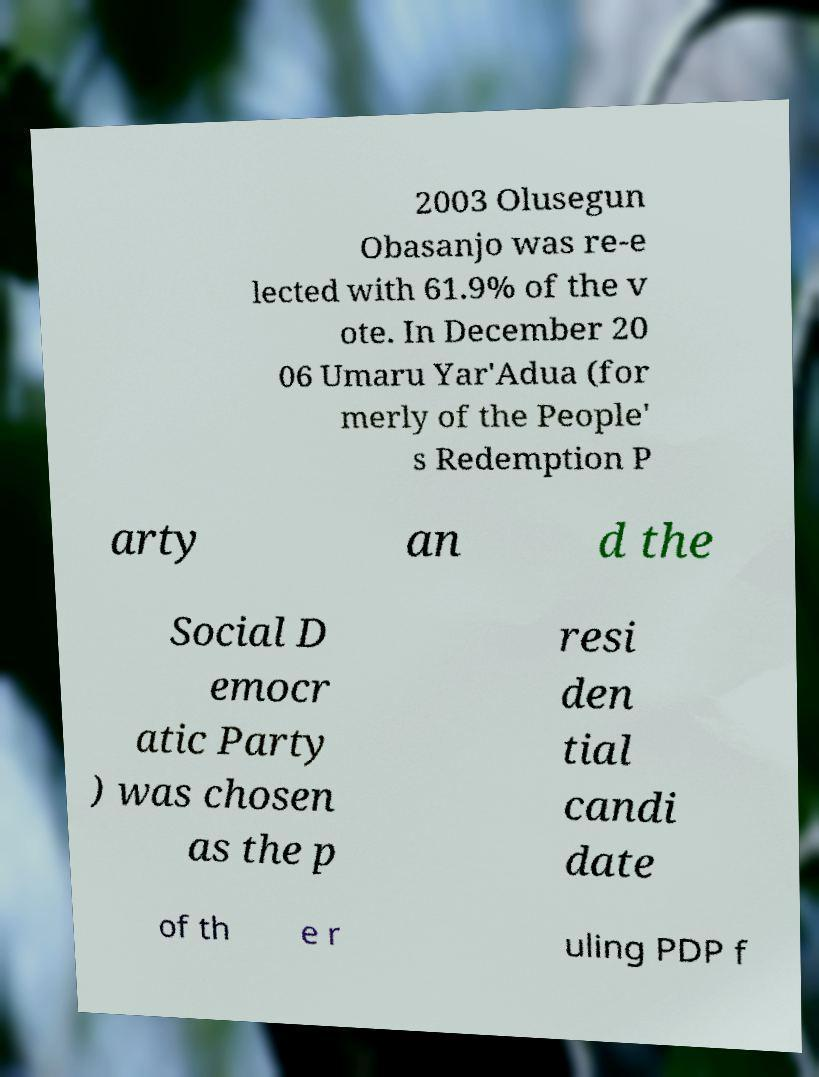Could you assist in decoding the text presented in this image and type it out clearly? 2003 Olusegun Obasanjo was re-e lected with 61.9% of the v ote. In December 20 06 Umaru Yar'Adua (for merly of the People' s Redemption P arty an d the Social D emocr atic Party ) was chosen as the p resi den tial candi date of th e r uling PDP f 